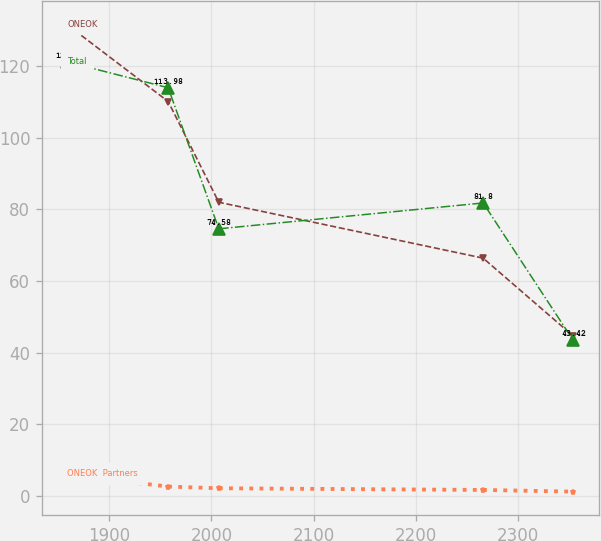Convert chart to OTSL. <chart><loc_0><loc_0><loc_500><loc_500><line_chart><ecel><fcel>ONEOK<fcel>ONEOK  Partners<fcel>Total<nl><fcel>1858.88<fcel>131.58<fcel>5.9<fcel>121.2<nl><fcel>1957.62<fcel>110.14<fcel>2.58<fcel>113.98<nl><fcel>2007.12<fcel>82<fcel>2.11<fcel>74.58<nl><fcel>2265.72<fcel>66.39<fcel>1.64<fcel>81.8<nl><fcel>2353.85<fcel>44.63<fcel>1.17<fcel>43.42<nl></chart> 